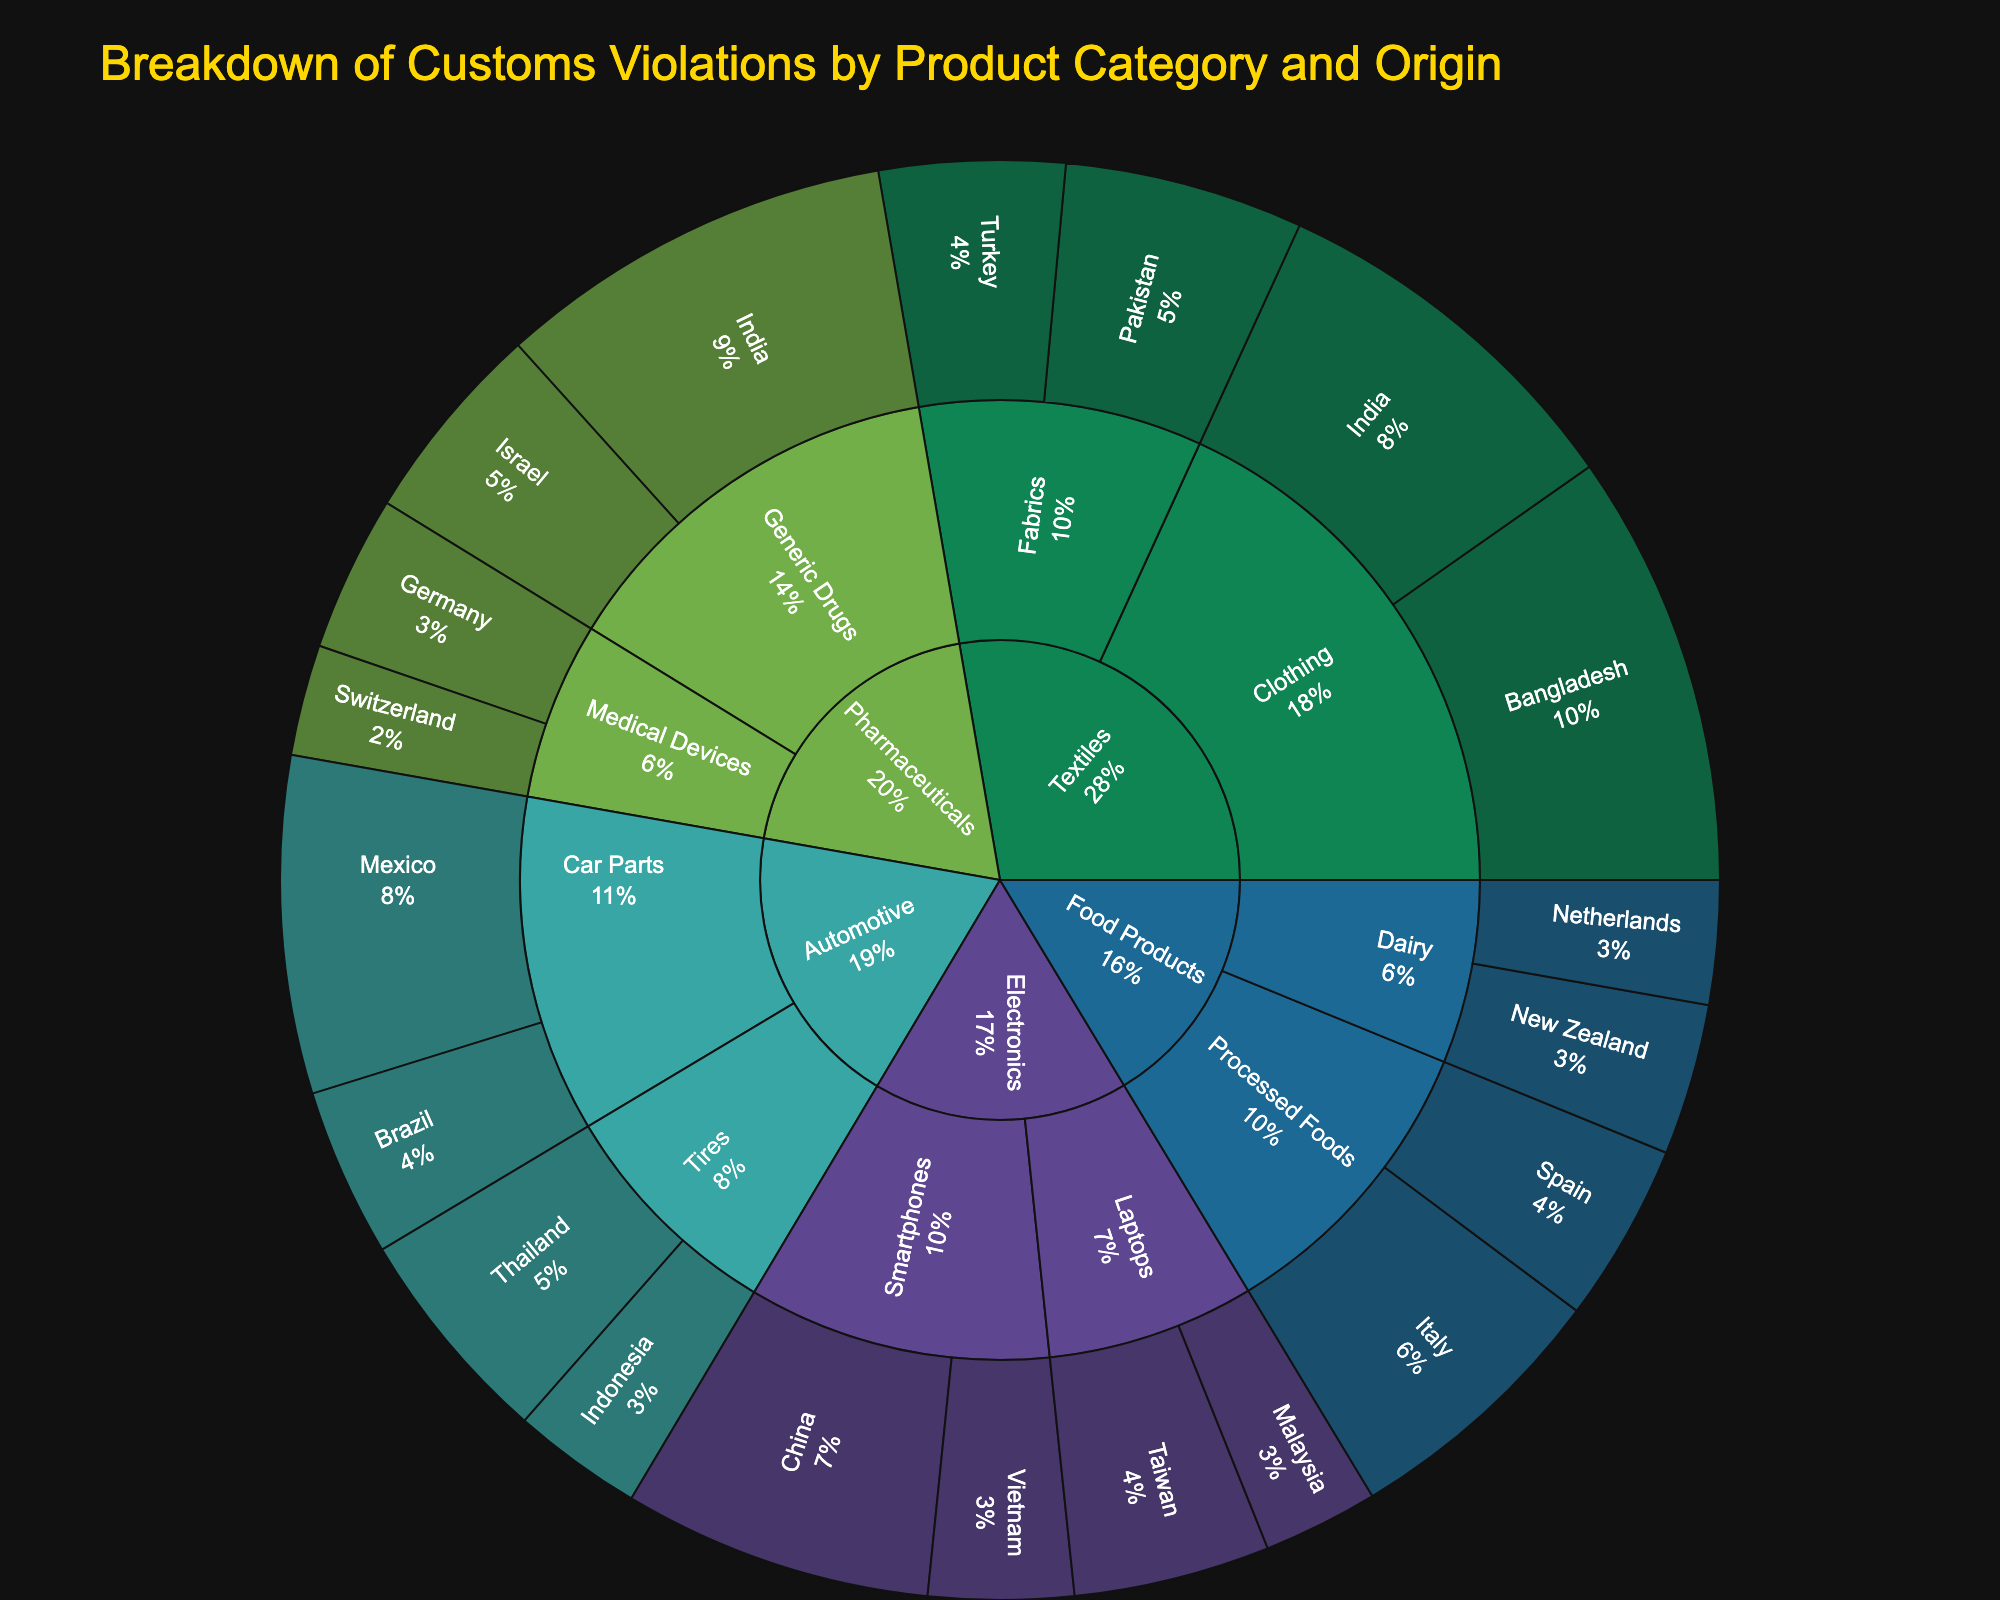What is the title of the sunburst plot? The title is located at the top of the sunburst plot and provides a summary of the information being visualized.
Answer: Breakdown of Customs Violations by Product Category and Origin Which category has the highest number of violations? By examining the size and labels of each category segment in the sunburst plot, one can identify the category with the largest representation in terms of violations.
Answer: Textiles What is the total number of violations in the Electronics category? Sum the violations from all subcategories and origins within the Electronics category: Smartphones (China: 145, Vietnam: 68) and Laptops (Taiwan: 92, Malaysia: 54). Total = 145 + 68 + 92 + 54
Answer: 359 How do violations from Pharmaceuticals: Generic Drugs in India compare to those in Israel? Compare the labels and sizes of the segments representing Generic Drugs from India and Israel to determine which has more violations.
Answer: India has more violations than Israel Which subcategory under Textiles has the second-highest number of violations? Within the Textiles category, look at the subcategories Clothing and Fabrics and compare their total violations.
Answer: Clothing in India What percentage of the total violations do Automotive Car Parts from Mexico represent? Calculate the percent by dividing the violations of Car Parts from Mexico (158) by the total violations (2038) and then multiplying by 100. (158 / 2038) * 100
Answer: Approximately 7.8% Between Food Products: Processed Foods from Italy and Spain, which has fewer violations? Locate the segments for Processed Foods from Italy and Spain and compare the violation numbers.
Answer: Spain How many origins are represented under the Dairy subcategory of Food Products? Identify the number of unique origins listed under Dairy from the sunburst plot.
Answer: 2 (New Zealand and Netherlands) What is the smallest category in terms of violations? By visually comparing the sizes of each main category segment, one can determine which has the fewest violations.
Answer: Pharmaceuticals What is the difference in the number of violations between Textiles: Fabrics from Pakistan and Turkey? Subtract the violations of Fabrics from Turkey (87) from those of Pakistan (112): 112 - 87
Answer: 25 